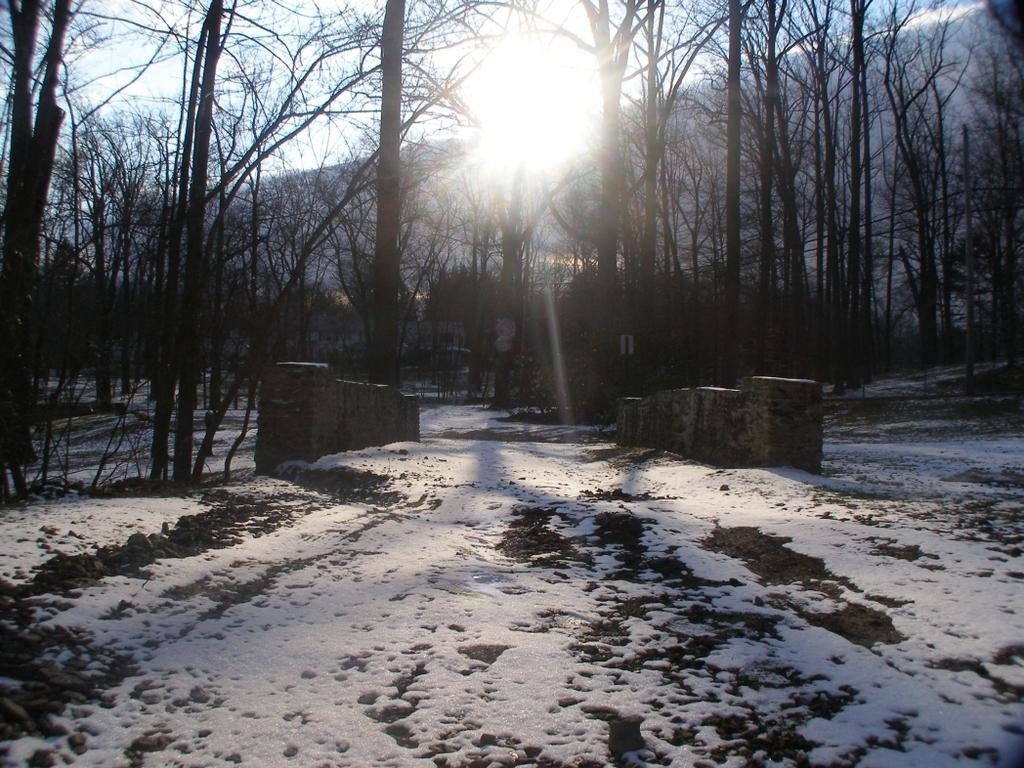What is covering is present on the ground in the image? There is snow on the ground in the image. What type of natural elements can be seen in the image? There are trees visible in the image. What is visible in the background of the image? The sky is visible in the background of the image. What type of book is the kitty reading in the image? There is no kitty or book present in the image; it features snow on the ground and trees. 